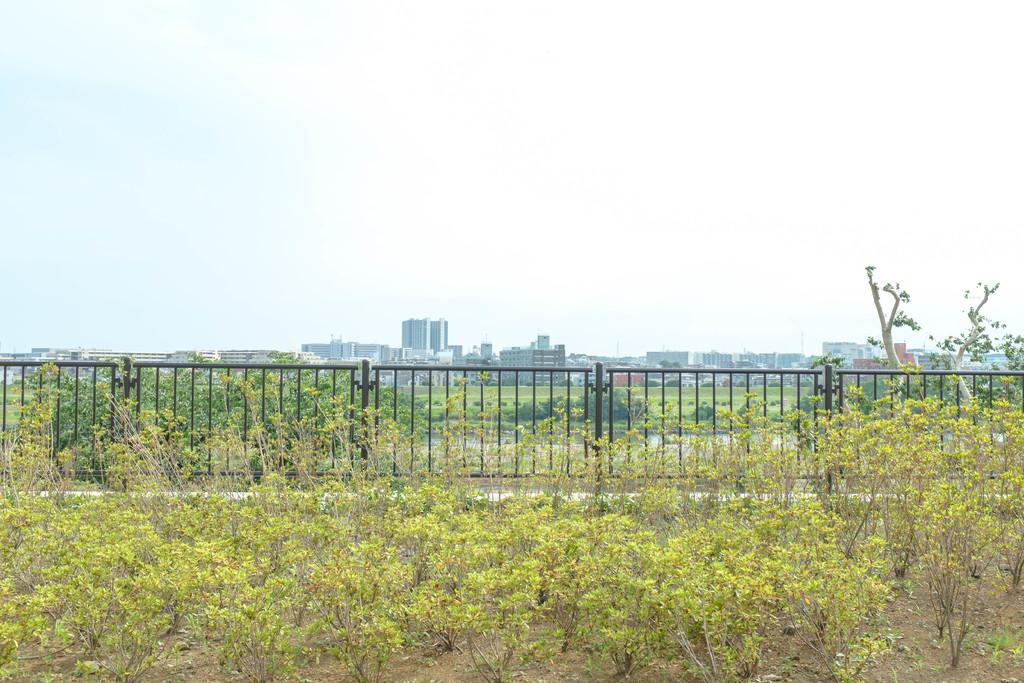How would you summarize this image in a sentence or two? In this image I can see the railing. To the side of the railing I can see many trees. In the background there are many buildings and the sky. 